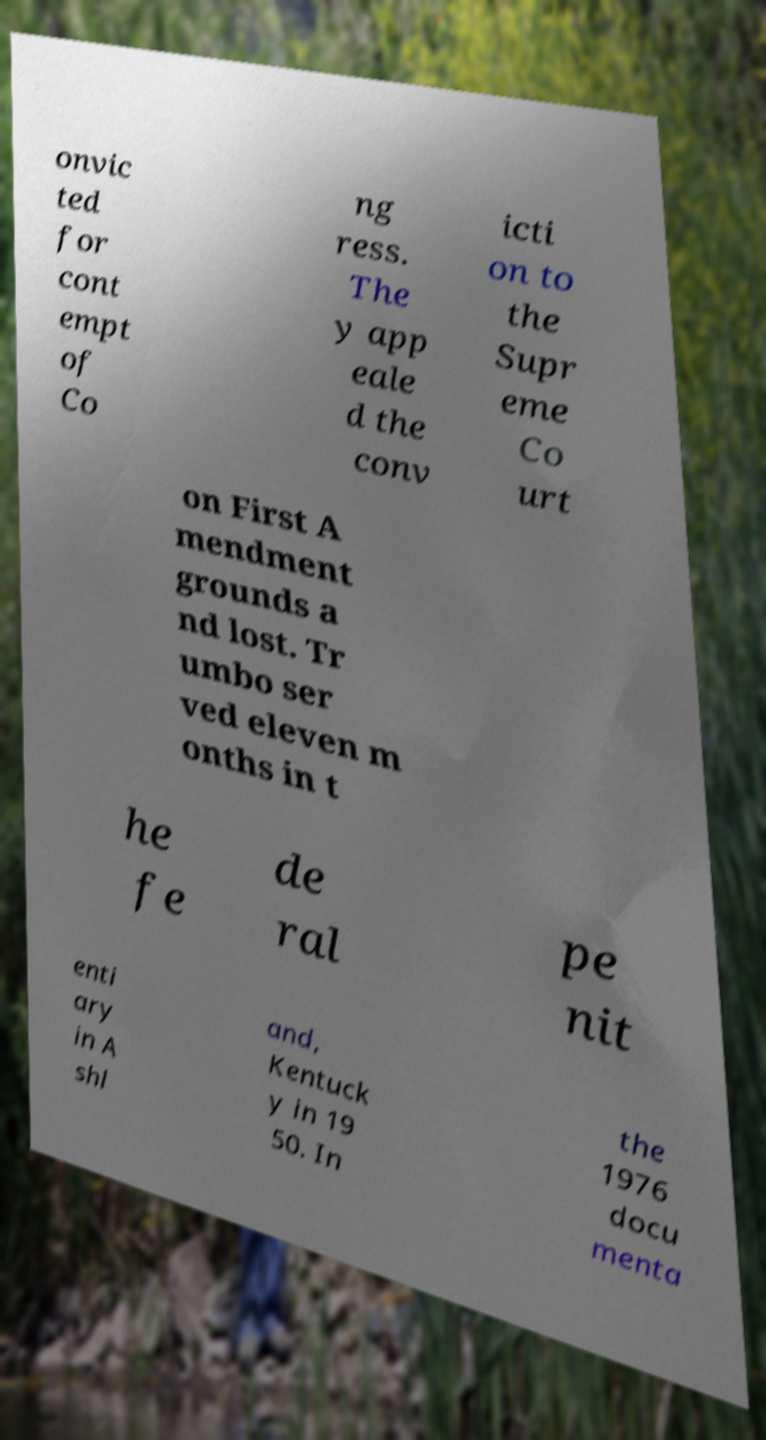Please read and relay the text visible in this image. What does it say? onvic ted for cont empt of Co ng ress. The y app eale d the conv icti on to the Supr eme Co urt on First A mendment grounds a nd lost. Tr umbo ser ved eleven m onths in t he fe de ral pe nit enti ary in A shl and, Kentuck y in 19 50. In the 1976 docu menta 